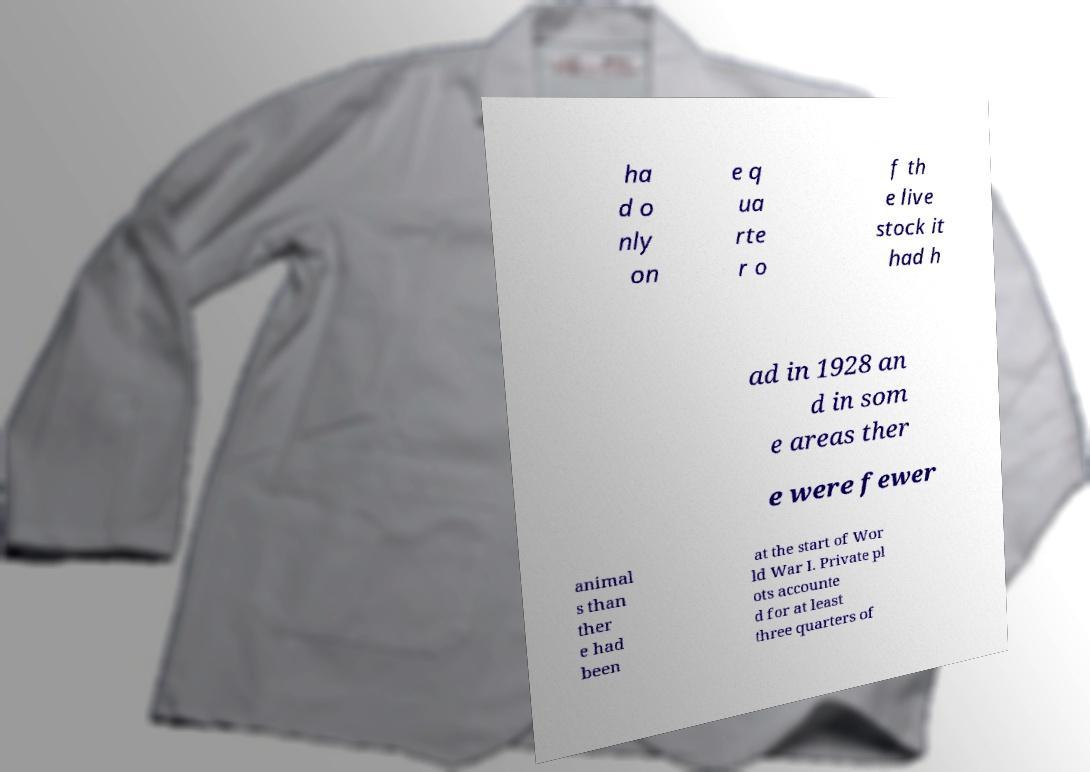What messages or text are displayed in this image? I need them in a readable, typed format. ha d o nly on e q ua rte r o f th e live stock it had h ad in 1928 an d in som e areas ther e were fewer animal s than ther e had been at the start of Wor ld War I. Private pl ots accounte d for at least three quarters of 